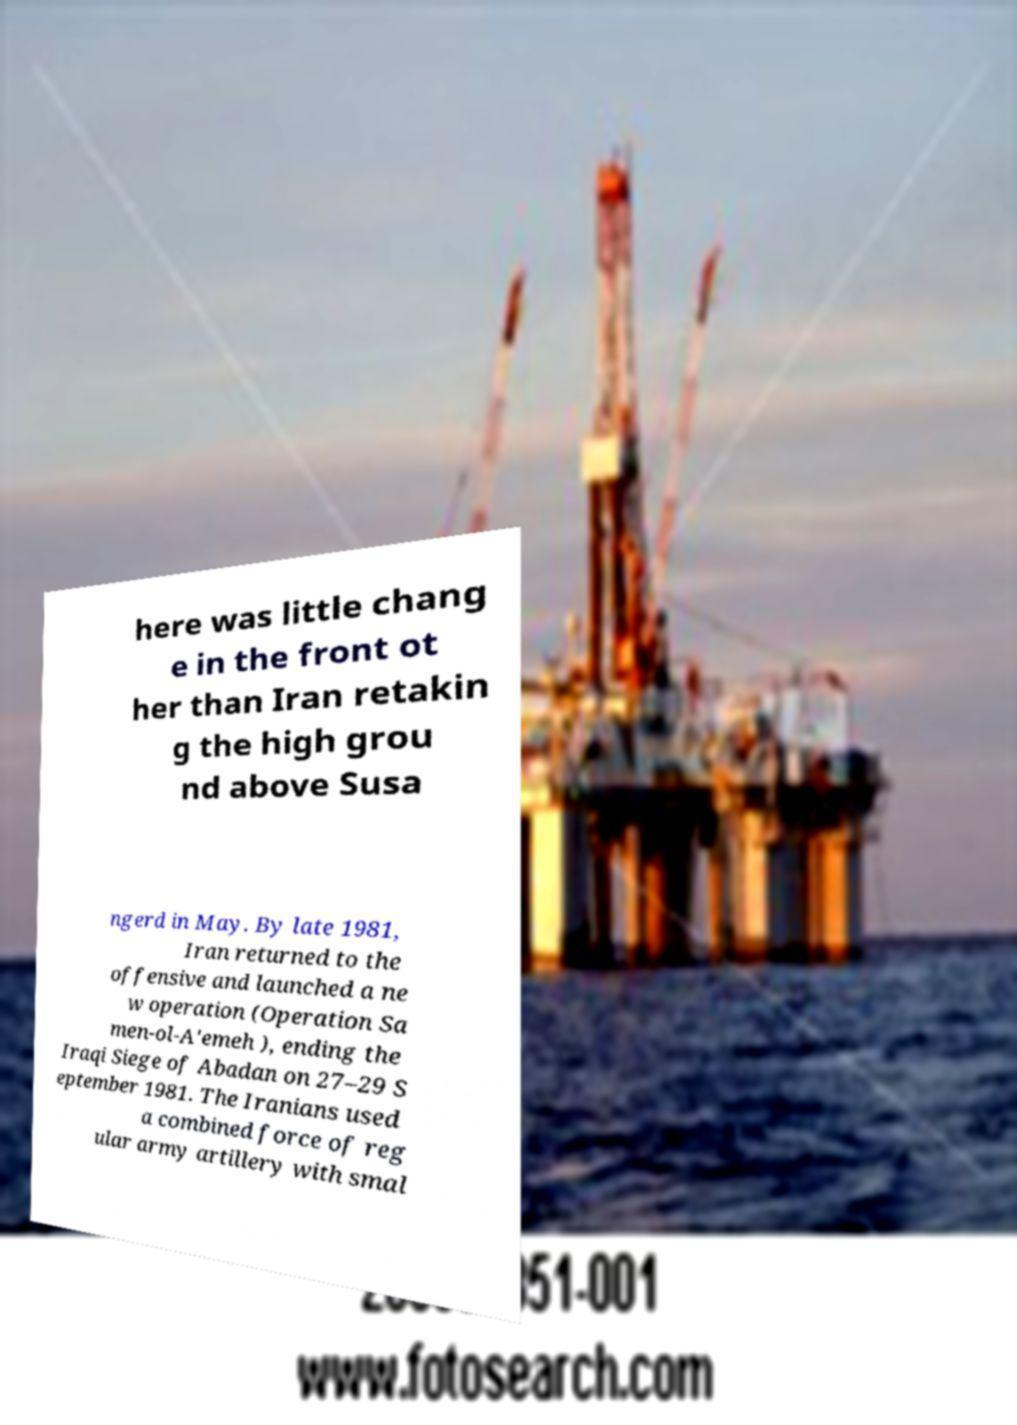There's text embedded in this image that I need extracted. Can you transcribe it verbatim? here was little chang e in the front ot her than Iran retakin g the high grou nd above Susa ngerd in May. By late 1981, Iran returned to the offensive and launched a ne w operation (Operation Sa men-ol-A'emeh ), ending the Iraqi Siege of Abadan on 27–29 S eptember 1981. The Iranians used a combined force of reg ular army artillery with smal 